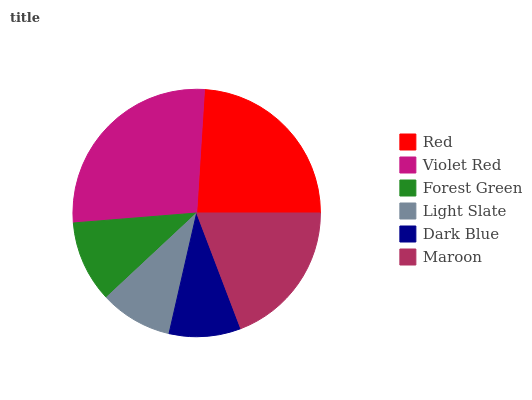Is Dark Blue the minimum?
Answer yes or no. Yes. Is Violet Red the maximum?
Answer yes or no. Yes. Is Forest Green the minimum?
Answer yes or no. No. Is Forest Green the maximum?
Answer yes or no. No. Is Violet Red greater than Forest Green?
Answer yes or no. Yes. Is Forest Green less than Violet Red?
Answer yes or no. Yes. Is Forest Green greater than Violet Red?
Answer yes or no. No. Is Violet Red less than Forest Green?
Answer yes or no. No. Is Maroon the high median?
Answer yes or no. Yes. Is Forest Green the low median?
Answer yes or no. Yes. Is Dark Blue the high median?
Answer yes or no. No. Is Light Slate the low median?
Answer yes or no. No. 